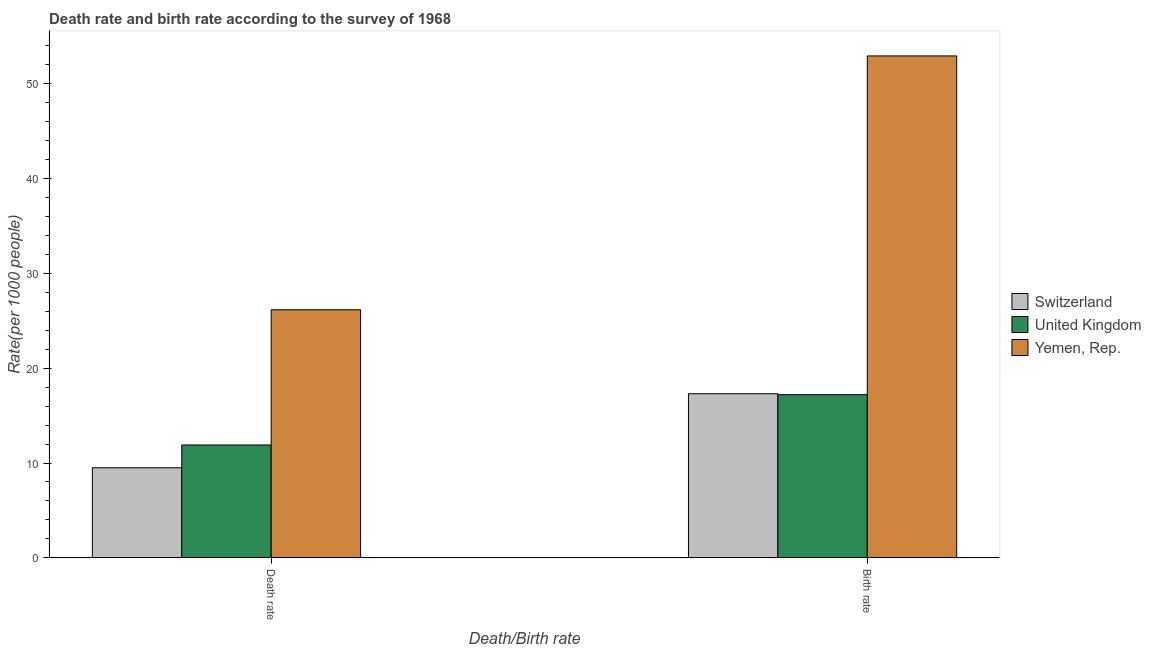How many different coloured bars are there?
Ensure brevity in your answer.  3. How many groups of bars are there?
Give a very brief answer. 2. Are the number of bars per tick equal to the number of legend labels?
Keep it short and to the point. Yes. Are the number of bars on each tick of the X-axis equal?
Keep it short and to the point. Yes. How many bars are there on the 2nd tick from the left?
Offer a very short reply. 3. What is the label of the 2nd group of bars from the left?
Keep it short and to the point. Birth rate. Across all countries, what is the maximum death rate?
Provide a succinct answer. 26.15. Across all countries, what is the minimum death rate?
Keep it short and to the point. 9.5. In which country was the death rate maximum?
Make the answer very short. Yemen, Rep. In which country was the birth rate minimum?
Provide a short and direct response. United Kingdom. What is the total death rate in the graph?
Your answer should be compact. 47.55. What is the difference between the death rate in Switzerland and that in Yemen, Rep.?
Ensure brevity in your answer.  -16.65. What is the difference between the death rate in Switzerland and the birth rate in United Kingdom?
Your response must be concise. -7.7. What is the average birth rate per country?
Ensure brevity in your answer.  29.13. What is the difference between the birth rate and death rate in United Kingdom?
Give a very brief answer. 5.3. What is the ratio of the birth rate in Yemen, Rep. to that in Switzerland?
Ensure brevity in your answer.  3.06. What does the 1st bar from the right in Death rate represents?
Offer a terse response. Yemen, Rep. How many bars are there?
Give a very brief answer. 6. How many countries are there in the graph?
Ensure brevity in your answer.  3. Are the values on the major ticks of Y-axis written in scientific E-notation?
Offer a terse response. No. Does the graph contain any zero values?
Your answer should be compact. No. Does the graph contain grids?
Make the answer very short. No. How many legend labels are there?
Your response must be concise. 3. What is the title of the graph?
Offer a terse response. Death rate and birth rate according to the survey of 1968. What is the label or title of the X-axis?
Offer a terse response. Death/Birth rate. What is the label or title of the Y-axis?
Offer a very short reply. Rate(per 1000 people). What is the Rate(per 1000 people) of Yemen, Rep. in Death rate?
Give a very brief answer. 26.15. What is the Rate(per 1000 people) of Switzerland in Birth rate?
Give a very brief answer. 17.3. What is the Rate(per 1000 people) of United Kingdom in Birth rate?
Offer a very short reply. 17.2. What is the Rate(per 1000 people) in Yemen, Rep. in Birth rate?
Your answer should be compact. 52.9. Across all Death/Birth rate, what is the maximum Rate(per 1000 people) of Yemen, Rep.?
Your response must be concise. 52.9. Across all Death/Birth rate, what is the minimum Rate(per 1000 people) in Yemen, Rep.?
Offer a terse response. 26.15. What is the total Rate(per 1000 people) of Switzerland in the graph?
Your answer should be very brief. 26.8. What is the total Rate(per 1000 people) of United Kingdom in the graph?
Offer a very short reply. 29.1. What is the total Rate(per 1000 people) of Yemen, Rep. in the graph?
Provide a succinct answer. 79.05. What is the difference between the Rate(per 1000 people) of Switzerland in Death rate and that in Birth rate?
Offer a terse response. -7.8. What is the difference between the Rate(per 1000 people) in Yemen, Rep. in Death rate and that in Birth rate?
Provide a short and direct response. -26.75. What is the difference between the Rate(per 1000 people) of Switzerland in Death rate and the Rate(per 1000 people) of United Kingdom in Birth rate?
Your response must be concise. -7.7. What is the difference between the Rate(per 1000 people) in Switzerland in Death rate and the Rate(per 1000 people) in Yemen, Rep. in Birth rate?
Give a very brief answer. -43.4. What is the difference between the Rate(per 1000 people) of United Kingdom in Death rate and the Rate(per 1000 people) of Yemen, Rep. in Birth rate?
Give a very brief answer. -41. What is the average Rate(per 1000 people) of Switzerland per Death/Birth rate?
Provide a short and direct response. 13.4. What is the average Rate(per 1000 people) of United Kingdom per Death/Birth rate?
Your response must be concise. 14.55. What is the average Rate(per 1000 people) of Yemen, Rep. per Death/Birth rate?
Provide a short and direct response. 39.53. What is the difference between the Rate(per 1000 people) in Switzerland and Rate(per 1000 people) in United Kingdom in Death rate?
Offer a terse response. -2.4. What is the difference between the Rate(per 1000 people) of Switzerland and Rate(per 1000 people) of Yemen, Rep. in Death rate?
Your response must be concise. -16.65. What is the difference between the Rate(per 1000 people) of United Kingdom and Rate(per 1000 people) of Yemen, Rep. in Death rate?
Make the answer very short. -14.25. What is the difference between the Rate(per 1000 people) in Switzerland and Rate(per 1000 people) in United Kingdom in Birth rate?
Your answer should be very brief. 0.1. What is the difference between the Rate(per 1000 people) of Switzerland and Rate(per 1000 people) of Yemen, Rep. in Birth rate?
Offer a very short reply. -35.6. What is the difference between the Rate(per 1000 people) of United Kingdom and Rate(per 1000 people) of Yemen, Rep. in Birth rate?
Make the answer very short. -35.7. What is the ratio of the Rate(per 1000 people) in Switzerland in Death rate to that in Birth rate?
Provide a succinct answer. 0.55. What is the ratio of the Rate(per 1000 people) in United Kingdom in Death rate to that in Birth rate?
Provide a short and direct response. 0.69. What is the ratio of the Rate(per 1000 people) of Yemen, Rep. in Death rate to that in Birth rate?
Keep it short and to the point. 0.49. What is the difference between the highest and the second highest Rate(per 1000 people) in Switzerland?
Ensure brevity in your answer.  7.8. What is the difference between the highest and the second highest Rate(per 1000 people) of Yemen, Rep.?
Provide a short and direct response. 26.75. What is the difference between the highest and the lowest Rate(per 1000 people) in Switzerland?
Your answer should be compact. 7.8. What is the difference between the highest and the lowest Rate(per 1000 people) in United Kingdom?
Offer a terse response. 5.3. What is the difference between the highest and the lowest Rate(per 1000 people) in Yemen, Rep.?
Give a very brief answer. 26.75. 